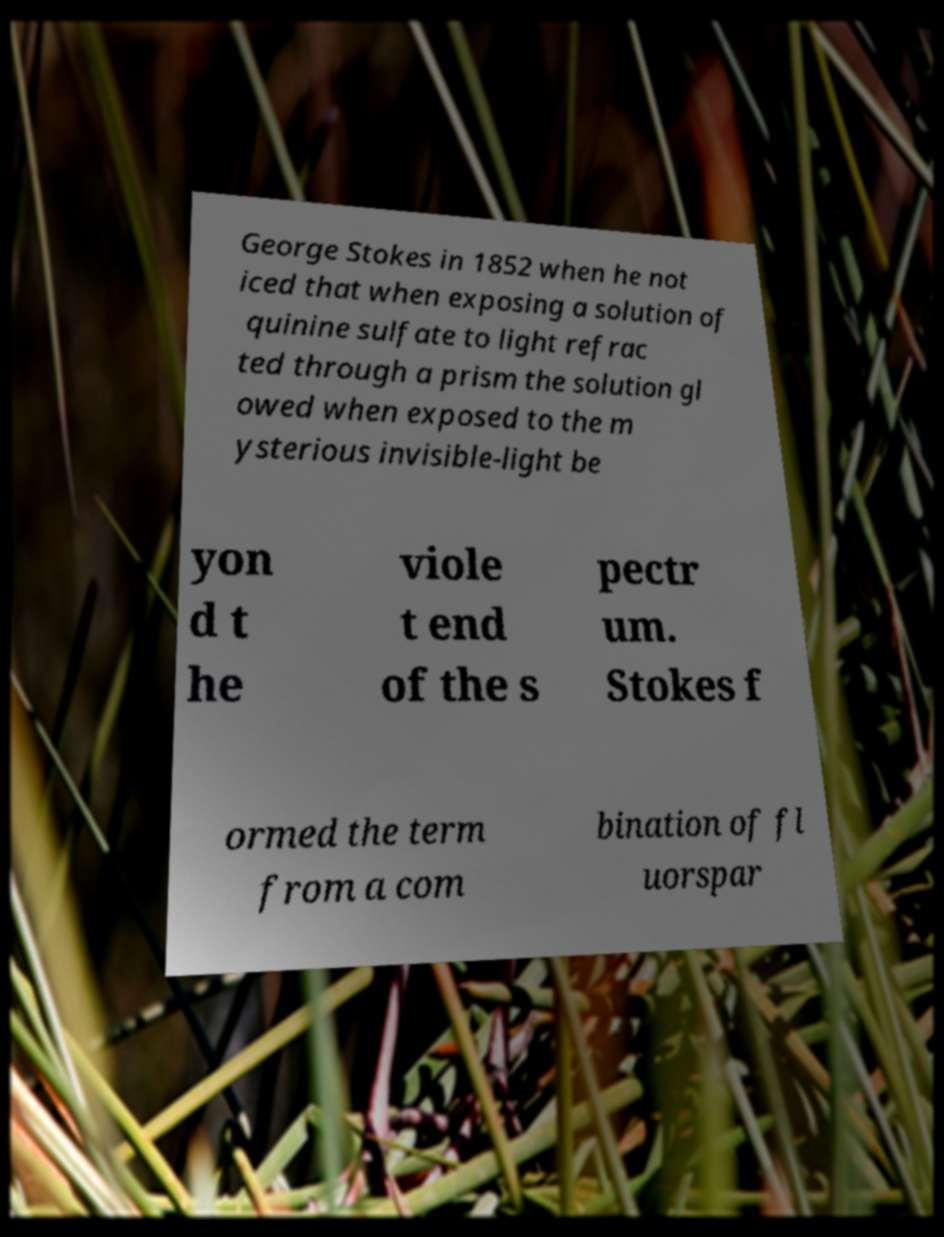Please read and relay the text visible in this image. What does it say? George Stokes in 1852 when he not iced that when exposing a solution of quinine sulfate to light refrac ted through a prism the solution gl owed when exposed to the m ysterious invisible-light be yon d t he viole t end of the s pectr um. Stokes f ormed the term from a com bination of fl uorspar 